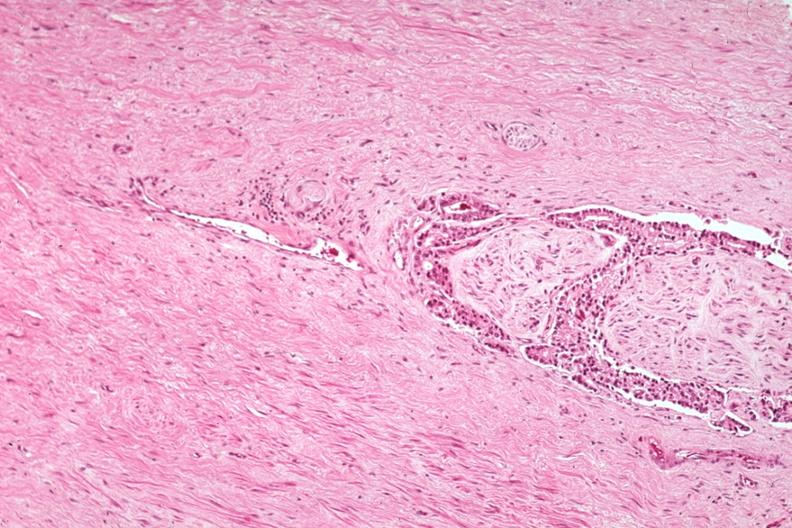what does this image show?
Answer the question using a single word or phrase. Med excellent example of perineural invasion 